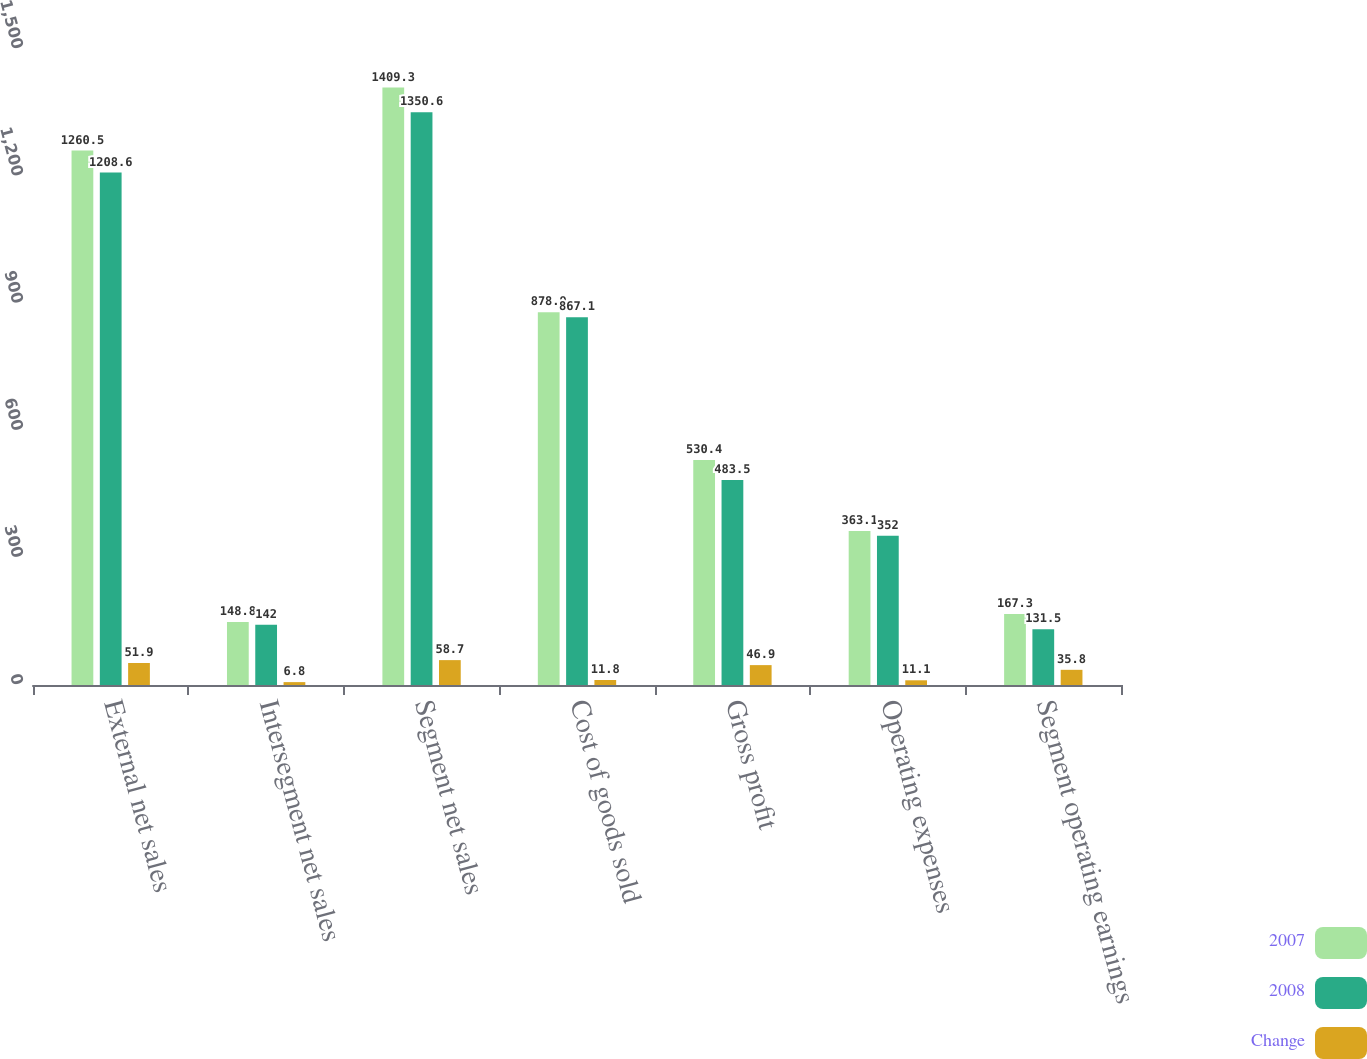<chart> <loc_0><loc_0><loc_500><loc_500><stacked_bar_chart><ecel><fcel>External net sales<fcel>Intersegment net sales<fcel>Segment net sales<fcel>Cost of goods sold<fcel>Gross profit<fcel>Operating expenses<fcel>Segment operating earnings<nl><fcel>2007<fcel>1260.5<fcel>148.8<fcel>1409.3<fcel>878.9<fcel>530.4<fcel>363.1<fcel>167.3<nl><fcel>2008<fcel>1208.6<fcel>142<fcel>1350.6<fcel>867.1<fcel>483.5<fcel>352<fcel>131.5<nl><fcel>Change<fcel>51.9<fcel>6.8<fcel>58.7<fcel>11.8<fcel>46.9<fcel>11.1<fcel>35.8<nl></chart> 